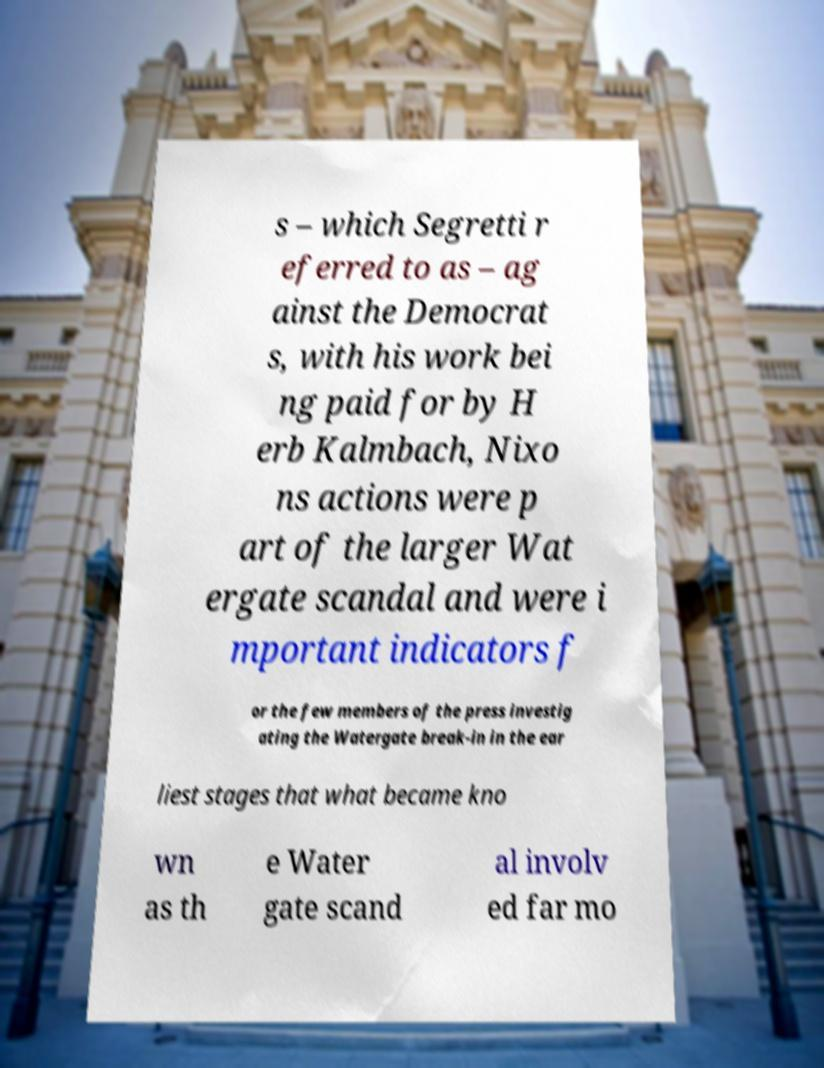What messages or text are displayed in this image? I need them in a readable, typed format. s – which Segretti r eferred to as – ag ainst the Democrat s, with his work bei ng paid for by H erb Kalmbach, Nixo ns actions were p art of the larger Wat ergate scandal and were i mportant indicators f or the few members of the press investig ating the Watergate break-in in the ear liest stages that what became kno wn as th e Water gate scand al involv ed far mo 